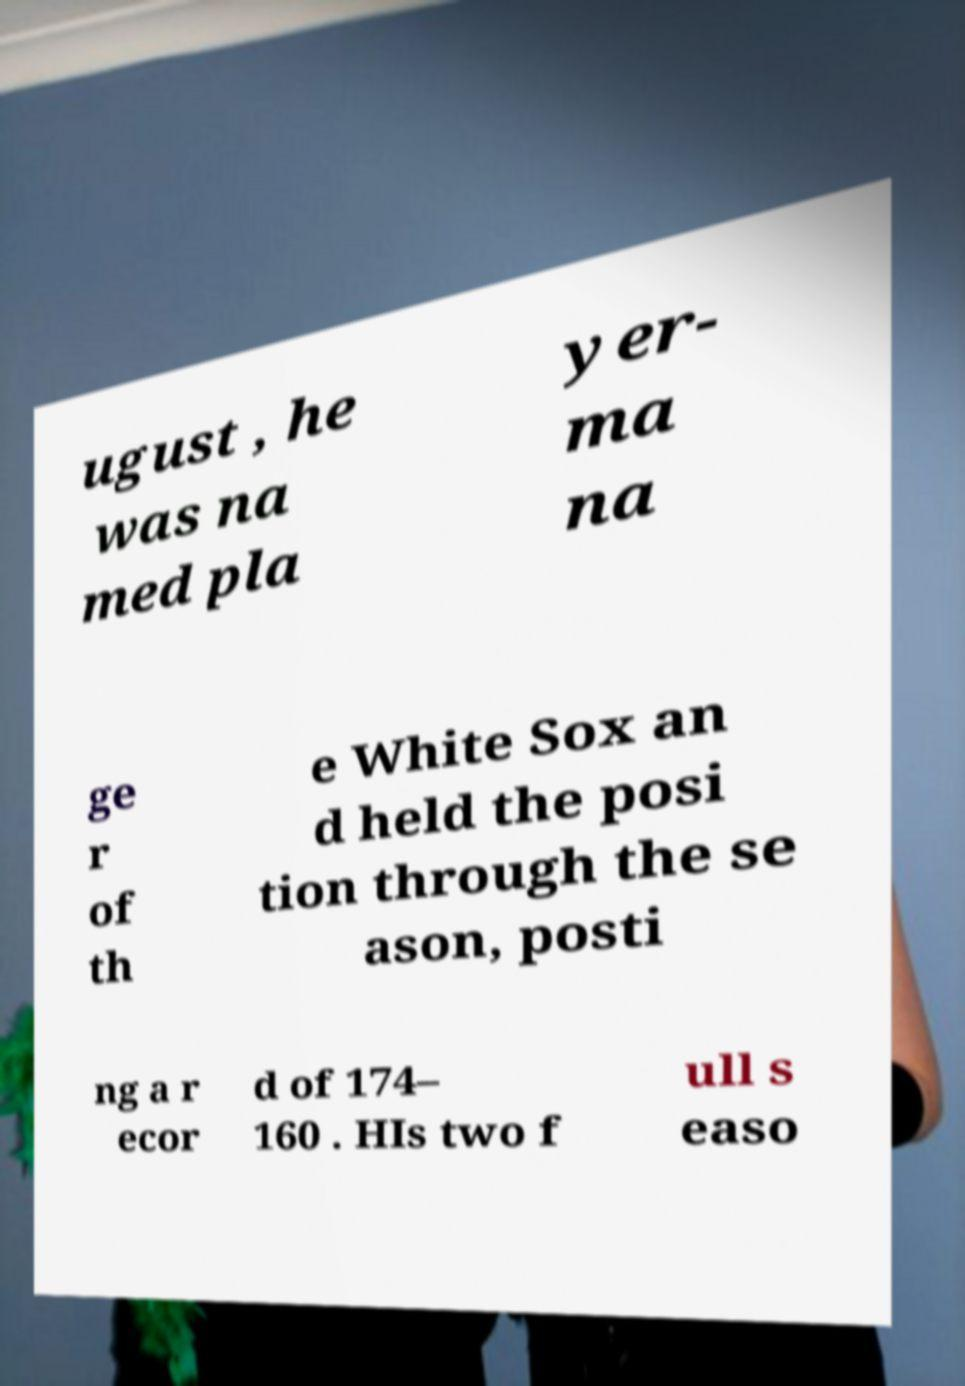Can you accurately transcribe the text from the provided image for me? ugust , he was na med pla yer- ma na ge r of th e White Sox an d held the posi tion through the se ason, posti ng a r ecor d of 174– 160 . HIs two f ull s easo 